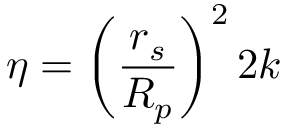Convert formula to latex. <formula><loc_0><loc_0><loc_500><loc_500>\eta = \left ( \frac { r _ { s } } { R _ { p } } \right ) ^ { 2 } 2 k</formula> 